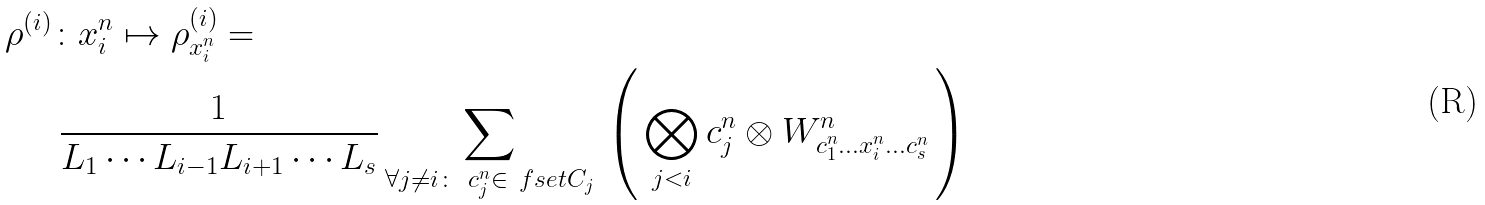Convert formula to latex. <formula><loc_0><loc_0><loc_500><loc_500>\rho ^ { ( i ) } & \colon x _ { i } ^ { n } \mapsto \rho _ { x _ { i } ^ { n } } ^ { ( i ) } = \\ & \, \frac { 1 } { L _ { 1 } \cdots L _ { i - 1 } L _ { i + 1 } \cdots L _ { s } } \sum _ { \forall j \neq i \colon \ c _ { j } ^ { n } \in \ f s e t { C } _ { j } } \, \left ( \, \bigotimes _ { j < i } c _ { j } ^ { n } \otimes W ^ { n } _ { c _ { 1 } ^ { n } \dots x ^ { n } _ { i } \dots c _ { s } ^ { n } } \, \right )</formula> 